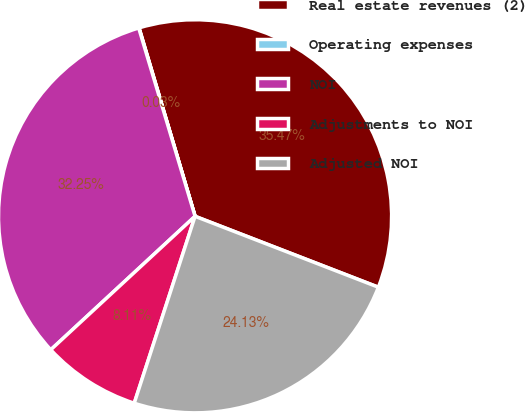Convert chart to OTSL. <chart><loc_0><loc_0><loc_500><loc_500><pie_chart><fcel>Real estate revenues (2)<fcel>Operating expenses<fcel>NOI<fcel>Adjustments to NOI<fcel>Adjusted NOI<nl><fcel>35.47%<fcel>0.03%<fcel>32.25%<fcel>8.11%<fcel>24.13%<nl></chart> 